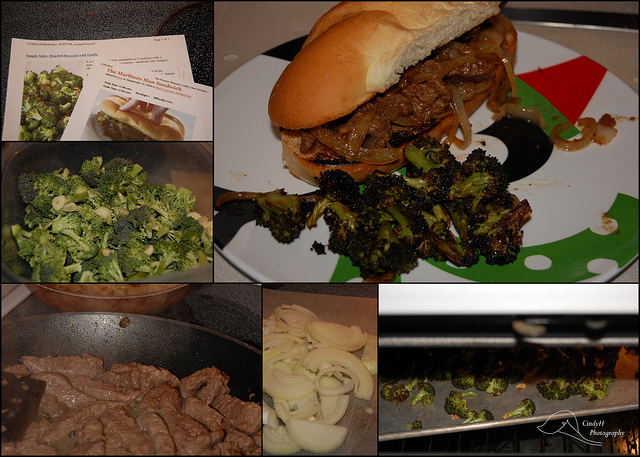Read all the text in this image. Photography 